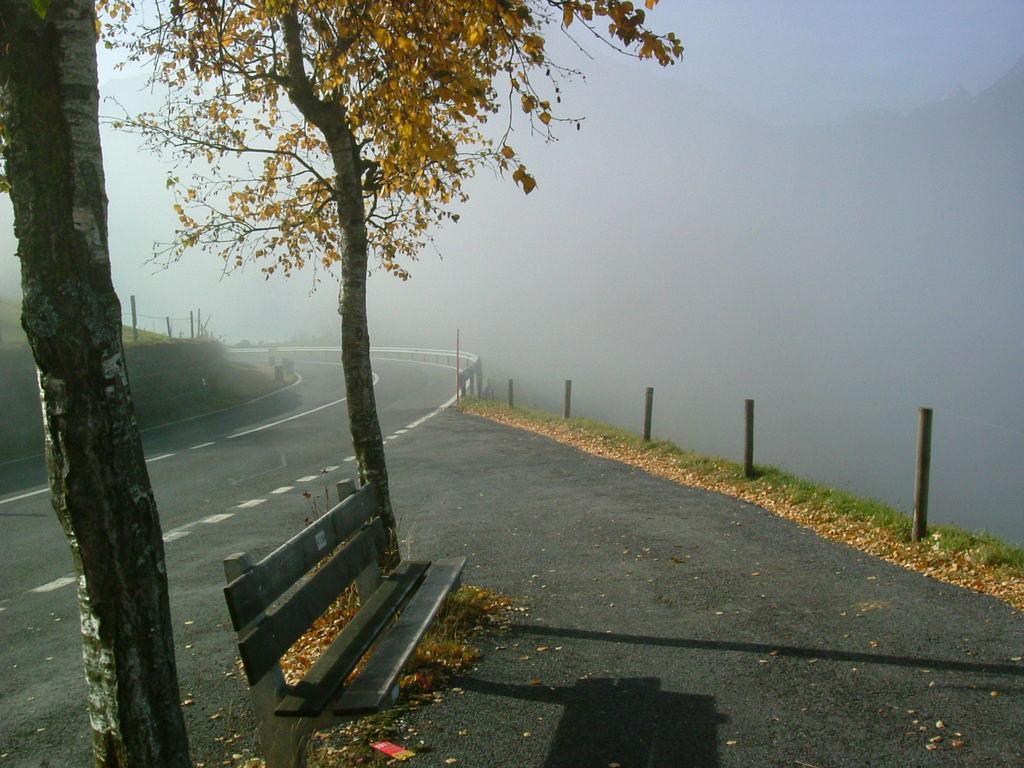Can you describe this image briefly? In this image we can see trees, bench, few rods, railing, road, and fog in the background. 